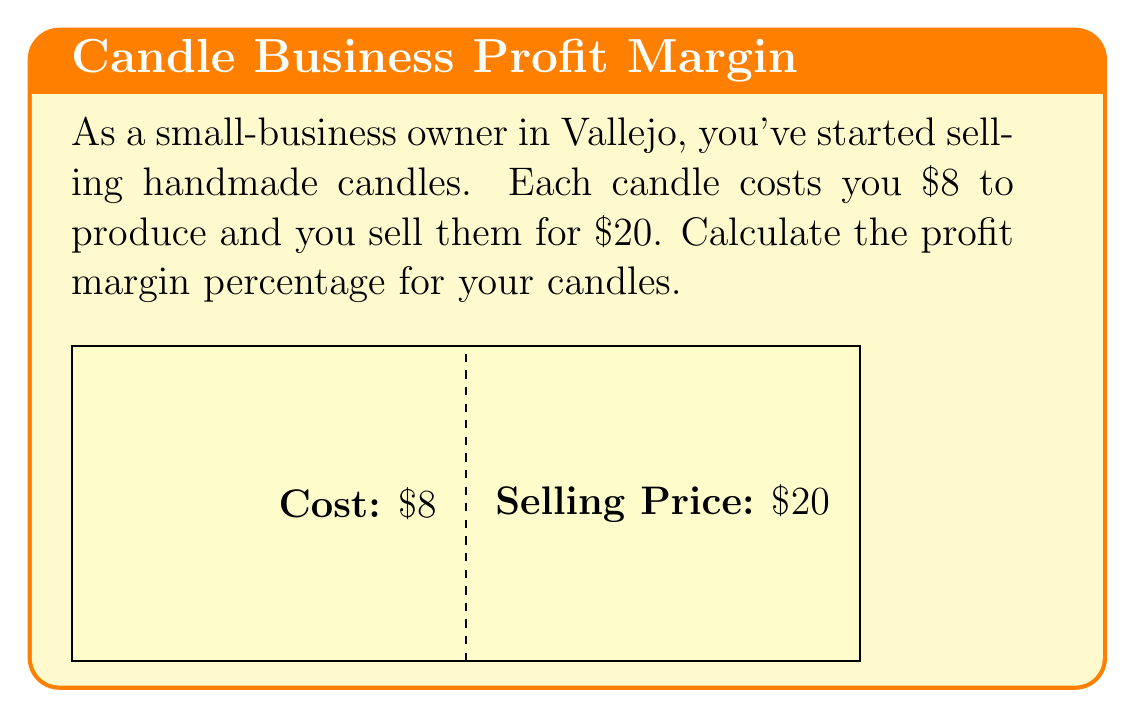Solve this math problem. To calculate the profit margin percentage, we need to follow these steps:

1) First, calculate the profit per candle:
   Profit = Selling Price - Cost
   $$ \text{Profit} = $20 - $8 = $12 $$

2) Next, calculate the profit margin:
   Profit Margin = Profit ÷ Selling Price
   $$ \text{Profit Margin} = \frac{$12}{$20} = 0.6 $$

3) To express this as a percentage, multiply by 100:
   Profit Margin Percentage = Profit Margin × 100
   $$ \text{Profit Margin Percentage} = 0.6 \times 100 = 60\% $$

Therefore, the profit margin percentage for your candles is 60%.
Answer: 60% 